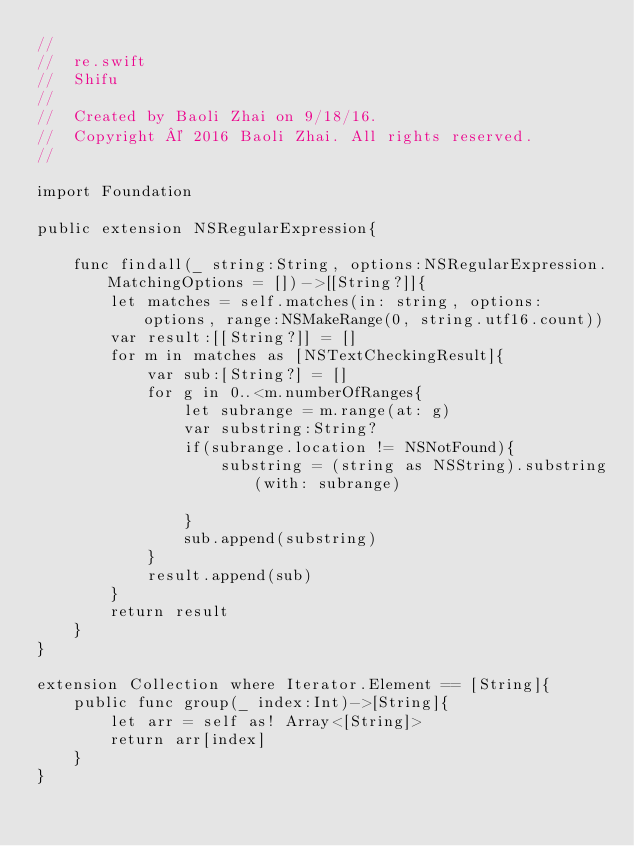<code> <loc_0><loc_0><loc_500><loc_500><_Swift_>//
//  re.swift
//  Shifu
//
//  Created by Baoli Zhai on 9/18/16.
//  Copyright © 2016 Baoli Zhai. All rights reserved.
//

import Foundation

public extension NSRegularExpression{
    
    func findall(_ string:String, options:NSRegularExpression.MatchingOptions = [])->[[String?]]{
        let matches = self.matches(in: string, options: options, range:NSMakeRange(0, string.utf16.count))
        var result:[[String?]] = []
        for m in matches as [NSTextCheckingResult]{
            var sub:[String?] = []
            for g in 0..<m.numberOfRanges{
                let subrange = m.range(at: g)
                var substring:String? 
                if(subrange.location != NSNotFound){
                    substring = (string as NSString).substring(with: subrange)
                    
                }
                sub.append(substring)
            }
            result.append(sub)
        }
        return result
    }
}

extension Collection where Iterator.Element == [String]{
    public func group(_ index:Int)->[String]{
        let arr = self as! Array<[String]>
        return arr[index]
    }
}
</code> 